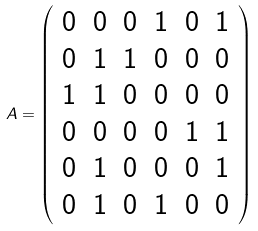Convert formula to latex. <formula><loc_0><loc_0><loc_500><loc_500>A = \left ( \begin{array} { c c c c c c } 0 & 0 & 0 & 1 & 0 & 1 \\ 0 & 1 & 1 & 0 & 0 & 0 \\ 1 & 1 & 0 & 0 & 0 & 0 \\ 0 & 0 & 0 & 0 & 1 & 1 \\ 0 & 1 & 0 & 0 & 0 & 1 \\ 0 & 1 & 0 & 1 & 0 & 0 \\ \end{array} \right )</formula> 